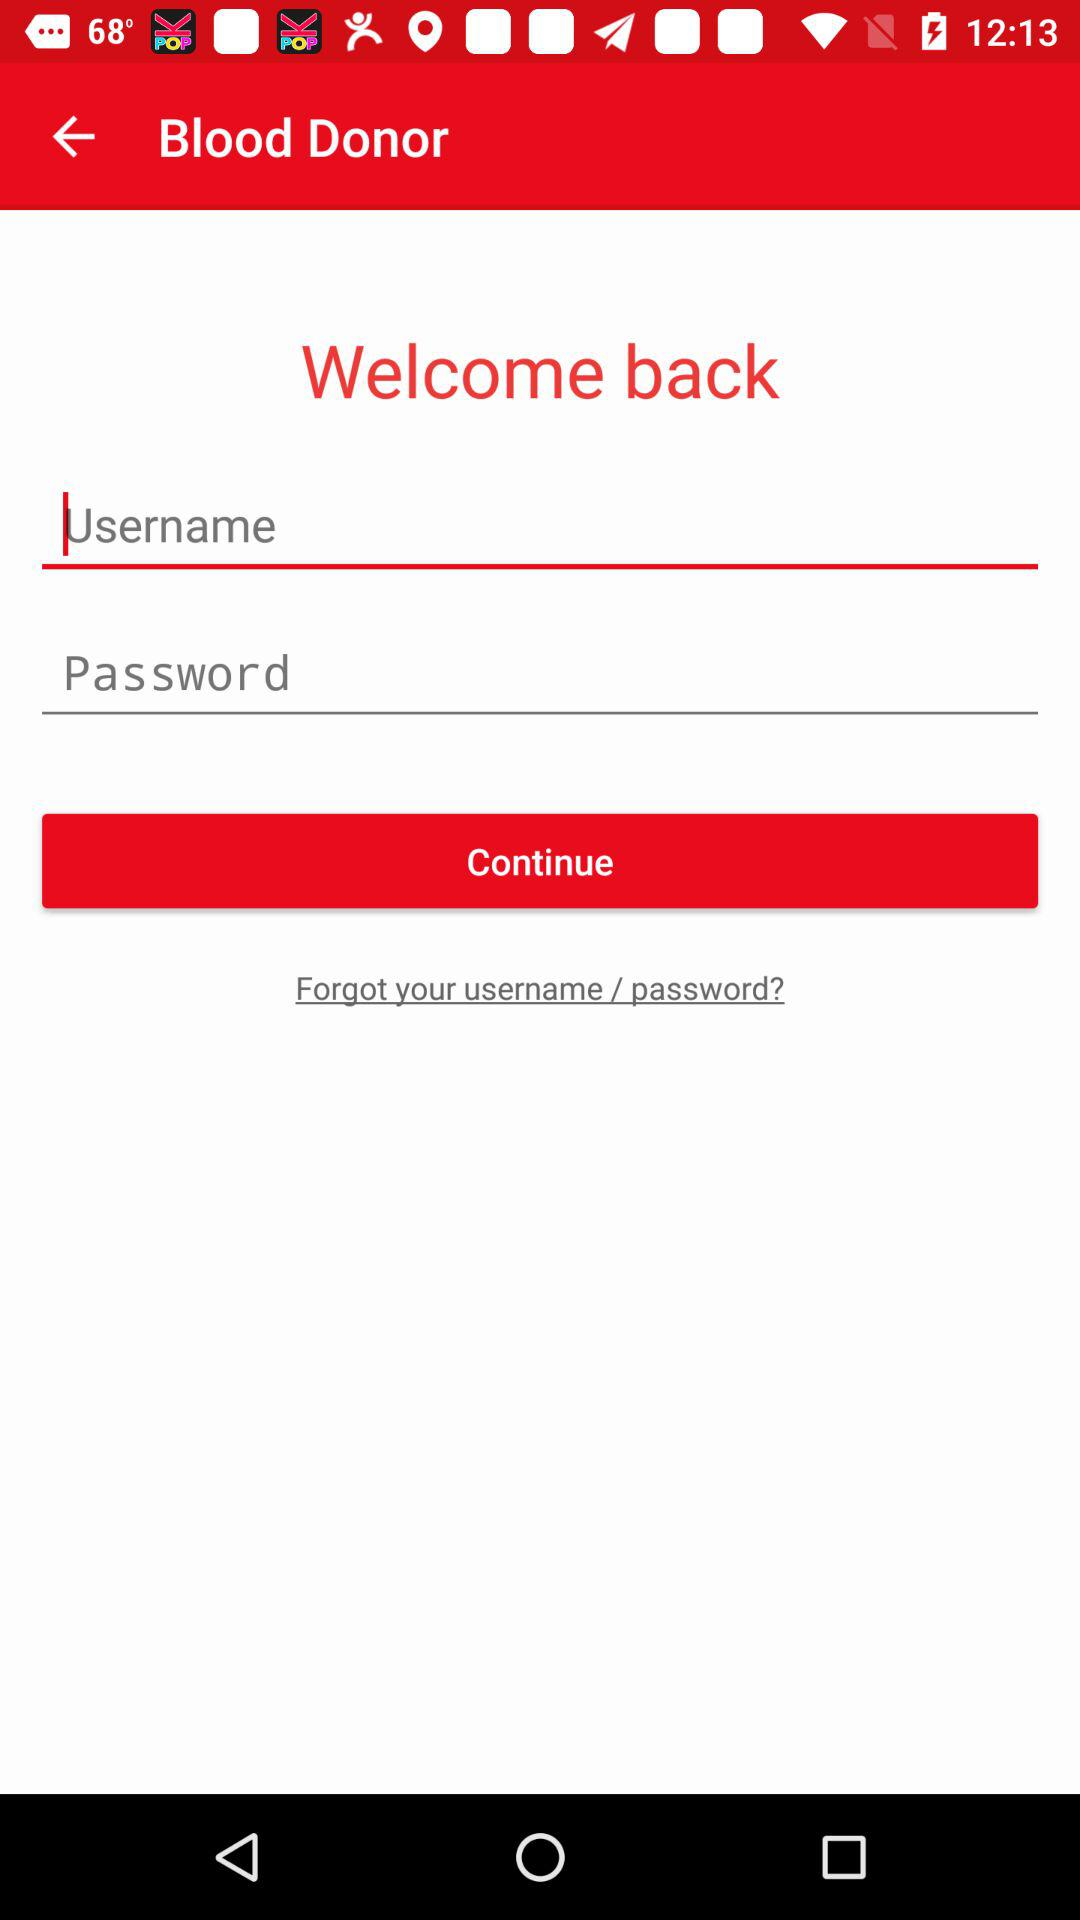What is the application name? The application name is Blood Donor. 